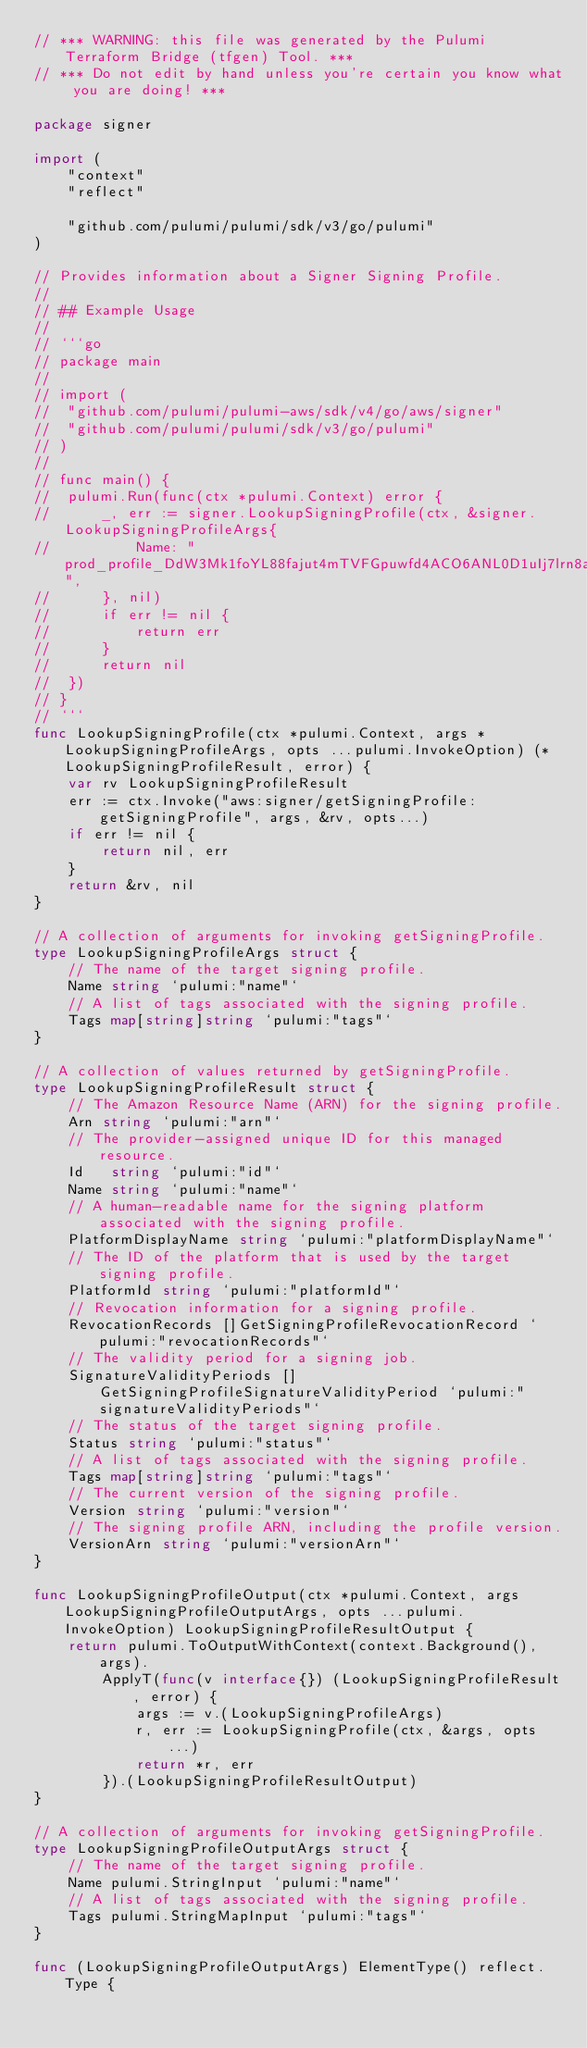<code> <loc_0><loc_0><loc_500><loc_500><_Go_>// *** WARNING: this file was generated by the Pulumi Terraform Bridge (tfgen) Tool. ***
// *** Do not edit by hand unless you're certain you know what you are doing! ***

package signer

import (
	"context"
	"reflect"

	"github.com/pulumi/pulumi/sdk/v3/go/pulumi"
)

// Provides information about a Signer Signing Profile.
//
// ## Example Usage
//
// ```go
// package main
//
// import (
// 	"github.com/pulumi/pulumi-aws/sdk/v4/go/aws/signer"
// 	"github.com/pulumi/pulumi/sdk/v3/go/pulumi"
// )
//
// func main() {
// 	pulumi.Run(func(ctx *pulumi.Context) error {
// 		_, err := signer.LookupSigningProfile(ctx, &signer.LookupSigningProfileArgs{
// 			Name: "prod_profile_DdW3Mk1foYL88fajut4mTVFGpuwfd4ACO6ANL0D1uIj7lrn8adK",
// 		}, nil)
// 		if err != nil {
// 			return err
// 		}
// 		return nil
// 	})
// }
// ```
func LookupSigningProfile(ctx *pulumi.Context, args *LookupSigningProfileArgs, opts ...pulumi.InvokeOption) (*LookupSigningProfileResult, error) {
	var rv LookupSigningProfileResult
	err := ctx.Invoke("aws:signer/getSigningProfile:getSigningProfile", args, &rv, opts...)
	if err != nil {
		return nil, err
	}
	return &rv, nil
}

// A collection of arguments for invoking getSigningProfile.
type LookupSigningProfileArgs struct {
	// The name of the target signing profile.
	Name string `pulumi:"name"`
	// A list of tags associated with the signing profile.
	Tags map[string]string `pulumi:"tags"`
}

// A collection of values returned by getSigningProfile.
type LookupSigningProfileResult struct {
	// The Amazon Resource Name (ARN) for the signing profile.
	Arn string `pulumi:"arn"`
	// The provider-assigned unique ID for this managed resource.
	Id   string `pulumi:"id"`
	Name string `pulumi:"name"`
	// A human-readable name for the signing platform associated with the signing profile.
	PlatformDisplayName string `pulumi:"platformDisplayName"`
	// The ID of the platform that is used by the target signing profile.
	PlatformId string `pulumi:"platformId"`
	// Revocation information for a signing profile.
	RevocationRecords []GetSigningProfileRevocationRecord `pulumi:"revocationRecords"`
	// The validity period for a signing job.
	SignatureValidityPeriods []GetSigningProfileSignatureValidityPeriod `pulumi:"signatureValidityPeriods"`
	// The status of the target signing profile.
	Status string `pulumi:"status"`
	// A list of tags associated with the signing profile.
	Tags map[string]string `pulumi:"tags"`
	// The current version of the signing profile.
	Version string `pulumi:"version"`
	// The signing profile ARN, including the profile version.
	VersionArn string `pulumi:"versionArn"`
}

func LookupSigningProfileOutput(ctx *pulumi.Context, args LookupSigningProfileOutputArgs, opts ...pulumi.InvokeOption) LookupSigningProfileResultOutput {
	return pulumi.ToOutputWithContext(context.Background(), args).
		ApplyT(func(v interface{}) (LookupSigningProfileResult, error) {
			args := v.(LookupSigningProfileArgs)
			r, err := LookupSigningProfile(ctx, &args, opts...)
			return *r, err
		}).(LookupSigningProfileResultOutput)
}

// A collection of arguments for invoking getSigningProfile.
type LookupSigningProfileOutputArgs struct {
	// The name of the target signing profile.
	Name pulumi.StringInput `pulumi:"name"`
	// A list of tags associated with the signing profile.
	Tags pulumi.StringMapInput `pulumi:"tags"`
}

func (LookupSigningProfileOutputArgs) ElementType() reflect.Type {</code> 